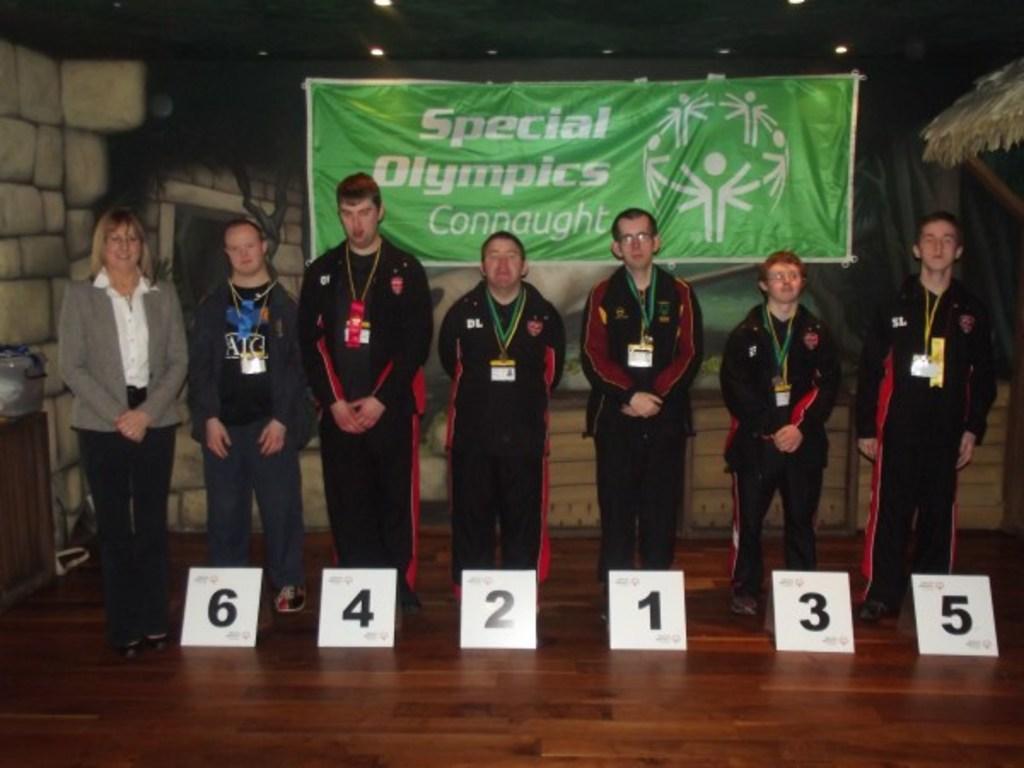Can you describe this image briefly? In this image we can see these people wearing black dresses are standing near the boards on the wooden floor and also this woman wearing blazer is standing here. In the background, we can see the green color banner with some text on it, the wall and the lights to the ceiling. 